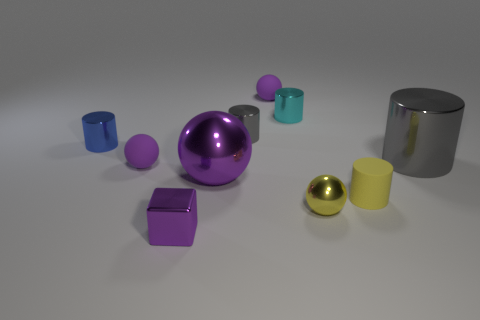How many purple spheres must be subtracted to get 1 purple spheres? 2 Subtract all green cylinders. How many purple spheres are left? 3 Subtract all tiny blue metal cylinders. How many cylinders are left? 4 Subtract 1 balls. How many balls are left? 3 Subtract all brown cylinders. Subtract all red balls. How many cylinders are left? 5 Subtract all spheres. How many objects are left? 6 Subtract all big purple things. Subtract all purple rubber objects. How many objects are left? 7 Add 2 purple blocks. How many purple blocks are left? 3 Add 8 purple cubes. How many purple cubes exist? 9 Subtract 0 red spheres. How many objects are left? 10 